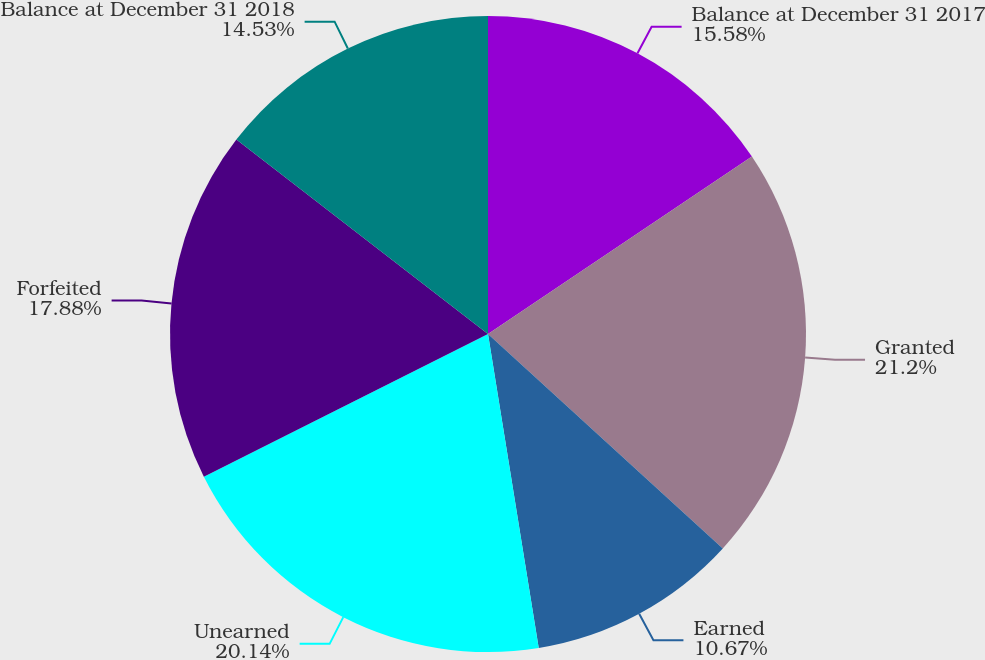<chart> <loc_0><loc_0><loc_500><loc_500><pie_chart><fcel>Balance at December 31 2017<fcel>Granted<fcel>Earned<fcel>Unearned<fcel>Forfeited<fcel>Balance at December 31 2018<nl><fcel>15.58%<fcel>21.2%<fcel>10.67%<fcel>20.14%<fcel>17.88%<fcel>14.53%<nl></chart> 